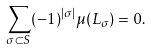Convert formula to latex. <formula><loc_0><loc_0><loc_500><loc_500>\sum _ { \sigma \subset S } ( - 1 ) ^ { | \sigma | } \mu ( L _ { \sigma } ) = 0 .</formula> 